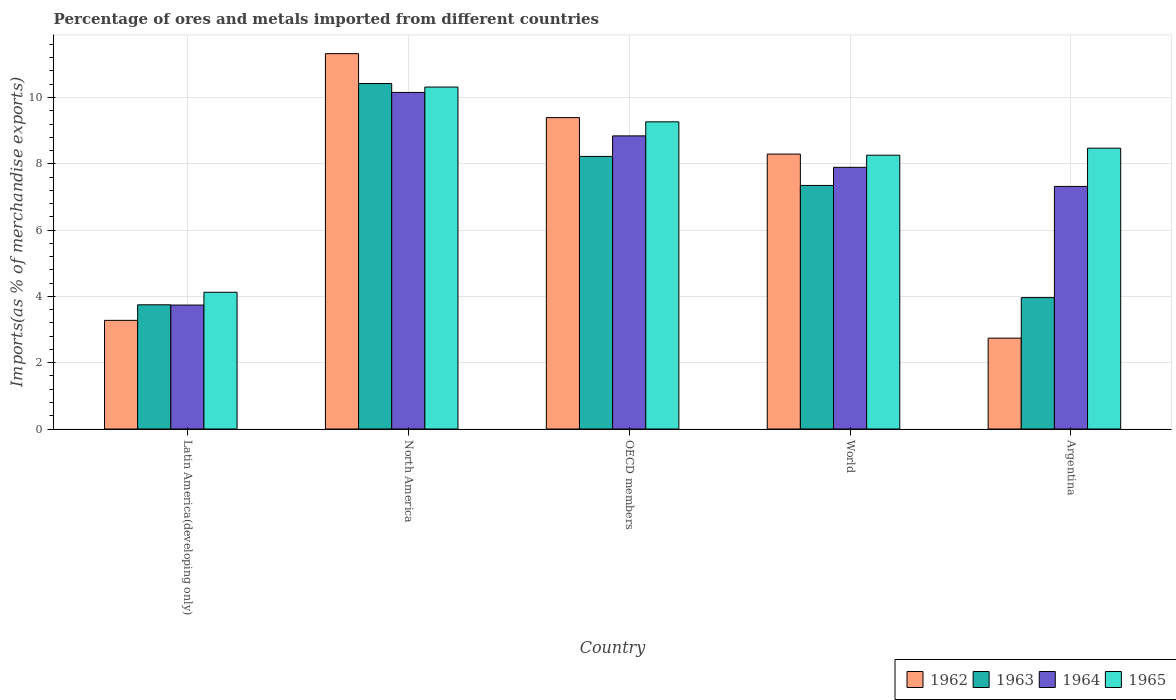How many different coloured bars are there?
Your answer should be very brief. 4. What is the label of the 1st group of bars from the left?
Your answer should be compact. Latin America(developing only). In how many cases, is the number of bars for a given country not equal to the number of legend labels?
Provide a succinct answer. 0. What is the percentage of imports to different countries in 1963 in North America?
Offer a very short reply. 10.42. Across all countries, what is the maximum percentage of imports to different countries in 1964?
Give a very brief answer. 10.15. Across all countries, what is the minimum percentage of imports to different countries in 1965?
Your answer should be compact. 4.13. In which country was the percentage of imports to different countries in 1962 maximum?
Your answer should be compact. North America. What is the total percentage of imports to different countries in 1965 in the graph?
Your answer should be compact. 40.44. What is the difference between the percentage of imports to different countries in 1962 in Argentina and that in North America?
Provide a short and direct response. -8.58. What is the difference between the percentage of imports to different countries in 1963 in World and the percentage of imports to different countries in 1962 in OECD members?
Provide a short and direct response. -2.05. What is the average percentage of imports to different countries in 1962 per country?
Your answer should be compact. 7.01. What is the difference between the percentage of imports to different countries of/in 1963 and percentage of imports to different countries of/in 1965 in OECD members?
Your response must be concise. -1.04. What is the ratio of the percentage of imports to different countries in 1965 in North America to that in OECD members?
Your response must be concise. 1.11. Is the percentage of imports to different countries in 1962 in Latin America(developing only) less than that in World?
Give a very brief answer. Yes. What is the difference between the highest and the second highest percentage of imports to different countries in 1965?
Offer a terse response. -0.79. What is the difference between the highest and the lowest percentage of imports to different countries in 1963?
Provide a short and direct response. 6.67. Is the sum of the percentage of imports to different countries in 1965 in Argentina and OECD members greater than the maximum percentage of imports to different countries in 1964 across all countries?
Ensure brevity in your answer.  Yes. Is it the case that in every country, the sum of the percentage of imports to different countries in 1963 and percentage of imports to different countries in 1964 is greater than the sum of percentage of imports to different countries in 1962 and percentage of imports to different countries in 1965?
Offer a terse response. No. What does the 3rd bar from the left in North America represents?
Provide a succinct answer. 1964. Is it the case that in every country, the sum of the percentage of imports to different countries in 1962 and percentage of imports to different countries in 1964 is greater than the percentage of imports to different countries in 1965?
Give a very brief answer. Yes. Are all the bars in the graph horizontal?
Make the answer very short. No. Are the values on the major ticks of Y-axis written in scientific E-notation?
Your answer should be very brief. No. Does the graph contain any zero values?
Provide a succinct answer. No. Where does the legend appear in the graph?
Keep it short and to the point. Bottom right. What is the title of the graph?
Keep it short and to the point. Percentage of ores and metals imported from different countries. What is the label or title of the Y-axis?
Your response must be concise. Imports(as % of merchandise exports). What is the Imports(as % of merchandise exports) of 1962 in Latin America(developing only)?
Provide a short and direct response. 3.28. What is the Imports(as % of merchandise exports) in 1963 in Latin America(developing only)?
Ensure brevity in your answer.  3.75. What is the Imports(as % of merchandise exports) in 1964 in Latin America(developing only)?
Your response must be concise. 3.74. What is the Imports(as % of merchandise exports) of 1965 in Latin America(developing only)?
Provide a short and direct response. 4.13. What is the Imports(as % of merchandise exports) in 1962 in North America?
Give a very brief answer. 11.32. What is the Imports(as % of merchandise exports) in 1963 in North America?
Offer a very short reply. 10.42. What is the Imports(as % of merchandise exports) in 1964 in North America?
Offer a very short reply. 10.15. What is the Imports(as % of merchandise exports) in 1965 in North America?
Your response must be concise. 10.31. What is the Imports(as % of merchandise exports) in 1962 in OECD members?
Provide a short and direct response. 9.39. What is the Imports(as % of merchandise exports) in 1963 in OECD members?
Offer a very short reply. 8.22. What is the Imports(as % of merchandise exports) in 1964 in OECD members?
Keep it short and to the point. 8.84. What is the Imports(as % of merchandise exports) of 1965 in OECD members?
Offer a terse response. 9.27. What is the Imports(as % of merchandise exports) in 1962 in World?
Offer a very short reply. 8.29. What is the Imports(as % of merchandise exports) in 1963 in World?
Ensure brevity in your answer.  7.35. What is the Imports(as % of merchandise exports) of 1964 in World?
Keep it short and to the point. 7.89. What is the Imports(as % of merchandise exports) of 1965 in World?
Give a very brief answer. 8.26. What is the Imports(as % of merchandise exports) of 1962 in Argentina?
Ensure brevity in your answer.  2.74. What is the Imports(as % of merchandise exports) in 1963 in Argentina?
Give a very brief answer. 3.96. What is the Imports(as % of merchandise exports) of 1964 in Argentina?
Your response must be concise. 7.32. What is the Imports(as % of merchandise exports) in 1965 in Argentina?
Your response must be concise. 8.47. Across all countries, what is the maximum Imports(as % of merchandise exports) of 1962?
Your response must be concise. 11.32. Across all countries, what is the maximum Imports(as % of merchandise exports) of 1963?
Offer a terse response. 10.42. Across all countries, what is the maximum Imports(as % of merchandise exports) of 1964?
Make the answer very short. 10.15. Across all countries, what is the maximum Imports(as % of merchandise exports) in 1965?
Offer a terse response. 10.31. Across all countries, what is the minimum Imports(as % of merchandise exports) of 1962?
Offer a terse response. 2.74. Across all countries, what is the minimum Imports(as % of merchandise exports) of 1963?
Make the answer very short. 3.75. Across all countries, what is the minimum Imports(as % of merchandise exports) in 1964?
Make the answer very short. 3.74. Across all countries, what is the minimum Imports(as % of merchandise exports) of 1965?
Keep it short and to the point. 4.13. What is the total Imports(as % of merchandise exports) of 1962 in the graph?
Your answer should be very brief. 35.03. What is the total Imports(as % of merchandise exports) of 1963 in the graph?
Your response must be concise. 33.7. What is the total Imports(as % of merchandise exports) in 1964 in the graph?
Provide a succinct answer. 37.95. What is the total Imports(as % of merchandise exports) in 1965 in the graph?
Provide a short and direct response. 40.44. What is the difference between the Imports(as % of merchandise exports) in 1962 in Latin America(developing only) and that in North America?
Your answer should be compact. -8.05. What is the difference between the Imports(as % of merchandise exports) of 1963 in Latin America(developing only) and that in North America?
Offer a very short reply. -6.67. What is the difference between the Imports(as % of merchandise exports) of 1964 in Latin America(developing only) and that in North America?
Offer a very short reply. -6.41. What is the difference between the Imports(as % of merchandise exports) of 1965 in Latin America(developing only) and that in North America?
Make the answer very short. -6.19. What is the difference between the Imports(as % of merchandise exports) of 1962 in Latin America(developing only) and that in OECD members?
Your answer should be very brief. -6.12. What is the difference between the Imports(as % of merchandise exports) of 1963 in Latin America(developing only) and that in OECD members?
Your answer should be compact. -4.48. What is the difference between the Imports(as % of merchandise exports) in 1964 in Latin America(developing only) and that in OECD members?
Give a very brief answer. -5.1. What is the difference between the Imports(as % of merchandise exports) in 1965 in Latin America(developing only) and that in OECD members?
Your answer should be compact. -5.14. What is the difference between the Imports(as % of merchandise exports) of 1962 in Latin America(developing only) and that in World?
Keep it short and to the point. -5.02. What is the difference between the Imports(as % of merchandise exports) of 1963 in Latin America(developing only) and that in World?
Your answer should be very brief. -3.6. What is the difference between the Imports(as % of merchandise exports) of 1964 in Latin America(developing only) and that in World?
Your answer should be compact. -4.15. What is the difference between the Imports(as % of merchandise exports) in 1965 in Latin America(developing only) and that in World?
Keep it short and to the point. -4.13. What is the difference between the Imports(as % of merchandise exports) of 1962 in Latin America(developing only) and that in Argentina?
Make the answer very short. 0.54. What is the difference between the Imports(as % of merchandise exports) of 1963 in Latin America(developing only) and that in Argentina?
Provide a succinct answer. -0.22. What is the difference between the Imports(as % of merchandise exports) of 1964 in Latin America(developing only) and that in Argentina?
Offer a very short reply. -3.58. What is the difference between the Imports(as % of merchandise exports) of 1965 in Latin America(developing only) and that in Argentina?
Give a very brief answer. -4.35. What is the difference between the Imports(as % of merchandise exports) of 1962 in North America and that in OECD members?
Make the answer very short. 1.93. What is the difference between the Imports(as % of merchandise exports) of 1963 in North America and that in OECD members?
Provide a succinct answer. 2.2. What is the difference between the Imports(as % of merchandise exports) of 1964 in North America and that in OECD members?
Make the answer very short. 1.31. What is the difference between the Imports(as % of merchandise exports) of 1965 in North America and that in OECD members?
Keep it short and to the point. 1.05. What is the difference between the Imports(as % of merchandise exports) of 1962 in North America and that in World?
Your answer should be compact. 3.03. What is the difference between the Imports(as % of merchandise exports) in 1963 in North America and that in World?
Provide a succinct answer. 3.07. What is the difference between the Imports(as % of merchandise exports) of 1964 in North America and that in World?
Offer a very short reply. 2.26. What is the difference between the Imports(as % of merchandise exports) in 1965 in North America and that in World?
Keep it short and to the point. 2.06. What is the difference between the Imports(as % of merchandise exports) of 1962 in North America and that in Argentina?
Your response must be concise. 8.58. What is the difference between the Imports(as % of merchandise exports) of 1963 in North America and that in Argentina?
Your answer should be very brief. 6.46. What is the difference between the Imports(as % of merchandise exports) of 1964 in North America and that in Argentina?
Give a very brief answer. 2.84. What is the difference between the Imports(as % of merchandise exports) of 1965 in North America and that in Argentina?
Give a very brief answer. 1.84. What is the difference between the Imports(as % of merchandise exports) in 1962 in OECD members and that in World?
Your response must be concise. 1.1. What is the difference between the Imports(as % of merchandise exports) in 1963 in OECD members and that in World?
Ensure brevity in your answer.  0.88. What is the difference between the Imports(as % of merchandise exports) in 1964 in OECD members and that in World?
Make the answer very short. 0.95. What is the difference between the Imports(as % of merchandise exports) of 1965 in OECD members and that in World?
Offer a very short reply. 1.01. What is the difference between the Imports(as % of merchandise exports) in 1962 in OECD members and that in Argentina?
Offer a terse response. 6.65. What is the difference between the Imports(as % of merchandise exports) of 1963 in OECD members and that in Argentina?
Your answer should be compact. 4.26. What is the difference between the Imports(as % of merchandise exports) of 1964 in OECD members and that in Argentina?
Provide a short and direct response. 1.52. What is the difference between the Imports(as % of merchandise exports) of 1965 in OECD members and that in Argentina?
Your answer should be very brief. 0.79. What is the difference between the Imports(as % of merchandise exports) in 1962 in World and that in Argentina?
Give a very brief answer. 5.55. What is the difference between the Imports(as % of merchandise exports) in 1963 in World and that in Argentina?
Offer a very short reply. 3.38. What is the difference between the Imports(as % of merchandise exports) in 1964 in World and that in Argentina?
Offer a terse response. 0.58. What is the difference between the Imports(as % of merchandise exports) in 1965 in World and that in Argentina?
Your answer should be compact. -0.21. What is the difference between the Imports(as % of merchandise exports) of 1962 in Latin America(developing only) and the Imports(as % of merchandise exports) of 1963 in North America?
Offer a terse response. -7.14. What is the difference between the Imports(as % of merchandise exports) of 1962 in Latin America(developing only) and the Imports(as % of merchandise exports) of 1964 in North America?
Provide a succinct answer. -6.88. What is the difference between the Imports(as % of merchandise exports) in 1962 in Latin America(developing only) and the Imports(as % of merchandise exports) in 1965 in North America?
Keep it short and to the point. -7.04. What is the difference between the Imports(as % of merchandise exports) in 1963 in Latin America(developing only) and the Imports(as % of merchandise exports) in 1964 in North America?
Offer a very short reply. -6.41. What is the difference between the Imports(as % of merchandise exports) of 1963 in Latin America(developing only) and the Imports(as % of merchandise exports) of 1965 in North America?
Your answer should be compact. -6.57. What is the difference between the Imports(as % of merchandise exports) in 1964 in Latin America(developing only) and the Imports(as % of merchandise exports) in 1965 in North America?
Provide a short and direct response. -6.58. What is the difference between the Imports(as % of merchandise exports) in 1962 in Latin America(developing only) and the Imports(as % of merchandise exports) in 1963 in OECD members?
Make the answer very short. -4.95. What is the difference between the Imports(as % of merchandise exports) of 1962 in Latin America(developing only) and the Imports(as % of merchandise exports) of 1964 in OECD members?
Give a very brief answer. -5.57. What is the difference between the Imports(as % of merchandise exports) in 1962 in Latin America(developing only) and the Imports(as % of merchandise exports) in 1965 in OECD members?
Provide a short and direct response. -5.99. What is the difference between the Imports(as % of merchandise exports) of 1963 in Latin America(developing only) and the Imports(as % of merchandise exports) of 1964 in OECD members?
Your response must be concise. -5.1. What is the difference between the Imports(as % of merchandise exports) in 1963 in Latin America(developing only) and the Imports(as % of merchandise exports) in 1965 in OECD members?
Your response must be concise. -5.52. What is the difference between the Imports(as % of merchandise exports) in 1964 in Latin America(developing only) and the Imports(as % of merchandise exports) in 1965 in OECD members?
Give a very brief answer. -5.53. What is the difference between the Imports(as % of merchandise exports) of 1962 in Latin America(developing only) and the Imports(as % of merchandise exports) of 1963 in World?
Provide a succinct answer. -4.07. What is the difference between the Imports(as % of merchandise exports) of 1962 in Latin America(developing only) and the Imports(as % of merchandise exports) of 1964 in World?
Keep it short and to the point. -4.62. What is the difference between the Imports(as % of merchandise exports) of 1962 in Latin America(developing only) and the Imports(as % of merchandise exports) of 1965 in World?
Offer a terse response. -4.98. What is the difference between the Imports(as % of merchandise exports) of 1963 in Latin America(developing only) and the Imports(as % of merchandise exports) of 1964 in World?
Offer a terse response. -4.15. What is the difference between the Imports(as % of merchandise exports) of 1963 in Latin America(developing only) and the Imports(as % of merchandise exports) of 1965 in World?
Offer a terse response. -4.51. What is the difference between the Imports(as % of merchandise exports) in 1964 in Latin America(developing only) and the Imports(as % of merchandise exports) in 1965 in World?
Offer a very short reply. -4.52. What is the difference between the Imports(as % of merchandise exports) of 1962 in Latin America(developing only) and the Imports(as % of merchandise exports) of 1963 in Argentina?
Keep it short and to the point. -0.69. What is the difference between the Imports(as % of merchandise exports) of 1962 in Latin America(developing only) and the Imports(as % of merchandise exports) of 1964 in Argentina?
Your response must be concise. -4.04. What is the difference between the Imports(as % of merchandise exports) of 1962 in Latin America(developing only) and the Imports(as % of merchandise exports) of 1965 in Argentina?
Provide a short and direct response. -5.19. What is the difference between the Imports(as % of merchandise exports) of 1963 in Latin America(developing only) and the Imports(as % of merchandise exports) of 1964 in Argentina?
Make the answer very short. -3.57. What is the difference between the Imports(as % of merchandise exports) of 1963 in Latin America(developing only) and the Imports(as % of merchandise exports) of 1965 in Argentina?
Provide a succinct answer. -4.73. What is the difference between the Imports(as % of merchandise exports) of 1964 in Latin America(developing only) and the Imports(as % of merchandise exports) of 1965 in Argentina?
Ensure brevity in your answer.  -4.73. What is the difference between the Imports(as % of merchandise exports) in 1962 in North America and the Imports(as % of merchandise exports) in 1963 in OECD members?
Provide a short and direct response. 3.1. What is the difference between the Imports(as % of merchandise exports) in 1962 in North America and the Imports(as % of merchandise exports) in 1964 in OECD members?
Your answer should be compact. 2.48. What is the difference between the Imports(as % of merchandise exports) in 1962 in North America and the Imports(as % of merchandise exports) in 1965 in OECD members?
Give a very brief answer. 2.06. What is the difference between the Imports(as % of merchandise exports) in 1963 in North America and the Imports(as % of merchandise exports) in 1964 in OECD members?
Keep it short and to the point. 1.58. What is the difference between the Imports(as % of merchandise exports) in 1963 in North America and the Imports(as % of merchandise exports) in 1965 in OECD members?
Offer a terse response. 1.16. What is the difference between the Imports(as % of merchandise exports) in 1964 in North America and the Imports(as % of merchandise exports) in 1965 in OECD members?
Your response must be concise. 0.89. What is the difference between the Imports(as % of merchandise exports) of 1962 in North America and the Imports(as % of merchandise exports) of 1963 in World?
Provide a short and direct response. 3.98. What is the difference between the Imports(as % of merchandise exports) of 1962 in North America and the Imports(as % of merchandise exports) of 1964 in World?
Ensure brevity in your answer.  3.43. What is the difference between the Imports(as % of merchandise exports) of 1962 in North America and the Imports(as % of merchandise exports) of 1965 in World?
Your answer should be compact. 3.06. What is the difference between the Imports(as % of merchandise exports) in 1963 in North America and the Imports(as % of merchandise exports) in 1964 in World?
Offer a very short reply. 2.53. What is the difference between the Imports(as % of merchandise exports) in 1963 in North America and the Imports(as % of merchandise exports) in 1965 in World?
Make the answer very short. 2.16. What is the difference between the Imports(as % of merchandise exports) in 1964 in North America and the Imports(as % of merchandise exports) in 1965 in World?
Provide a succinct answer. 1.89. What is the difference between the Imports(as % of merchandise exports) in 1962 in North America and the Imports(as % of merchandise exports) in 1963 in Argentina?
Your answer should be compact. 7.36. What is the difference between the Imports(as % of merchandise exports) of 1962 in North America and the Imports(as % of merchandise exports) of 1964 in Argentina?
Give a very brief answer. 4. What is the difference between the Imports(as % of merchandise exports) in 1962 in North America and the Imports(as % of merchandise exports) in 1965 in Argentina?
Your response must be concise. 2.85. What is the difference between the Imports(as % of merchandise exports) of 1963 in North America and the Imports(as % of merchandise exports) of 1964 in Argentina?
Provide a short and direct response. 3.1. What is the difference between the Imports(as % of merchandise exports) of 1963 in North America and the Imports(as % of merchandise exports) of 1965 in Argentina?
Provide a short and direct response. 1.95. What is the difference between the Imports(as % of merchandise exports) of 1964 in North America and the Imports(as % of merchandise exports) of 1965 in Argentina?
Give a very brief answer. 1.68. What is the difference between the Imports(as % of merchandise exports) of 1962 in OECD members and the Imports(as % of merchandise exports) of 1963 in World?
Offer a terse response. 2.05. What is the difference between the Imports(as % of merchandise exports) of 1962 in OECD members and the Imports(as % of merchandise exports) of 1964 in World?
Provide a short and direct response. 1.5. What is the difference between the Imports(as % of merchandise exports) in 1962 in OECD members and the Imports(as % of merchandise exports) in 1965 in World?
Offer a very short reply. 1.13. What is the difference between the Imports(as % of merchandise exports) in 1963 in OECD members and the Imports(as % of merchandise exports) in 1964 in World?
Make the answer very short. 0.33. What is the difference between the Imports(as % of merchandise exports) of 1963 in OECD members and the Imports(as % of merchandise exports) of 1965 in World?
Your response must be concise. -0.04. What is the difference between the Imports(as % of merchandise exports) of 1964 in OECD members and the Imports(as % of merchandise exports) of 1965 in World?
Your response must be concise. 0.58. What is the difference between the Imports(as % of merchandise exports) of 1962 in OECD members and the Imports(as % of merchandise exports) of 1963 in Argentina?
Your answer should be compact. 5.43. What is the difference between the Imports(as % of merchandise exports) of 1962 in OECD members and the Imports(as % of merchandise exports) of 1964 in Argentina?
Provide a succinct answer. 2.08. What is the difference between the Imports(as % of merchandise exports) in 1962 in OECD members and the Imports(as % of merchandise exports) in 1965 in Argentina?
Provide a succinct answer. 0.92. What is the difference between the Imports(as % of merchandise exports) of 1963 in OECD members and the Imports(as % of merchandise exports) of 1964 in Argentina?
Your response must be concise. 0.9. What is the difference between the Imports(as % of merchandise exports) in 1963 in OECD members and the Imports(as % of merchandise exports) in 1965 in Argentina?
Provide a succinct answer. -0.25. What is the difference between the Imports(as % of merchandise exports) in 1964 in OECD members and the Imports(as % of merchandise exports) in 1965 in Argentina?
Your answer should be very brief. 0.37. What is the difference between the Imports(as % of merchandise exports) in 1962 in World and the Imports(as % of merchandise exports) in 1963 in Argentina?
Your response must be concise. 4.33. What is the difference between the Imports(as % of merchandise exports) of 1962 in World and the Imports(as % of merchandise exports) of 1964 in Argentina?
Provide a short and direct response. 0.98. What is the difference between the Imports(as % of merchandise exports) of 1962 in World and the Imports(as % of merchandise exports) of 1965 in Argentina?
Ensure brevity in your answer.  -0.18. What is the difference between the Imports(as % of merchandise exports) in 1963 in World and the Imports(as % of merchandise exports) in 1964 in Argentina?
Provide a succinct answer. 0.03. What is the difference between the Imports(as % of merchandise exports) of 1963 in World and the Imports(as % of merchandise exports) of 1965 in Argentina?
Make the answer very short. -1.12. What is the difference between the Imports(as % of merchandise exports) of 1964 in World and the Imports(as % of merchandise exports) of 1965 in Argentina?
Keep it short and to the point. -0.58. What is the average Imports(as % of merchandise exports) of 1962 per country?
Make the answer very short. 7.01. What is the average Imports(as % of merchandise exports) of 1963 per country?
Give a very brief answer. 6.74. What is the average Imports(as % of merchandise exports) of 1964 per country?
Keep it short and to the point. 7.59. What is the average Imports(as % of merchandise exports) in 1965 per country?
Offer a terse response. 8.09. What is the difference between the Imports(as % of merchandise exports) in 1962 and Imports(as % of merchandise exports) in 1963 in Latin America(developing only)?
Your answer should be compact. -0.47. What is the difference between the Imports(as % of merchandise exports) in 1962 and Imports(as % of merchandise exports) in 1964 in Latin America(developing only)?
Offer a terse response. -0.46. What is the difference between the Imports(as % of merchandise exports) of 1962 and Imports(as % of merchandise exports) of 1965 in Latin America(developing only)?
Provide a succinct answer. -0.85. What is the difference between the Imports(as % of merchandise exports) of 1963 and Imports(as % of merchandise exports) of 1964 in Latin America(developing only)?
Offer a very short reply. 0.01. What is the difference between the Imports(as % of merchandise exports) in 1963 and Imports(as % of merchandise exports) in 1965 in Latin America(developing only)?
Provide a succinct answer. -0.38. What is the difference between the Imports(as % of merchandise exports) in 1964 and Imports(as % of merchandise exports) in 1965 in Latin America(developing only)?
Your response must be concise. -0.39. What is the difference between the Imports(as % of merchandise exports) of 1962 and Imports(as % of merchandise exports) of 1963 in North America?
Offer a very short reply. 0.9. What is the difference between the Imports(as % of merchandise exports) of 1962 and Imports(as % of merchandise exports) of 1964 in North America?
Provide a short and direct response. 1.17. What is the difference between the Imports(as % of merchandise exports) in 1963 and Imports(as % of merchandise exports) in 1964 in North America?
Ensure brevity in your answer.  0.27. What is the difference between the Imports(as % of merchandise exports) of 1963 and Imports(as % of merchandise exports) of 1965 in North America?
Offer a terse response. 0.11. What is the difference between the Imports(as % of merchandise exports) of 1964 and Imports(as % of merchandise exports) of 1965 in North America?
Offer a terse response. -0.16. What is the difference between the Imports(as % of merchandise exports) of 1962 and Imports(as % of merchandise exports) of 1963 in OECD members?
Provide a short and direct response. 1.17. What is the difference between the Imports(as % of merchandise exports) in 1962 and Imports(as % of merchandise exports) in 1964 in OECD members?
Give a very brief answer. 0.55. What is the difference between the Imports(as % of merchandise exports) of 1962 and Imports(as % of merchandise exports) of 1965 in OECD members?
Your answer should be very brief. 0.13. What is the difference between the Imports(as % of merchandise exports) of 1963 and Imports(as % of merchandise exports) of 1964 in OECD members?
Keep it short and to the point. -0.62. What is the difference between the Imports(as % of merchandise exports) in 1963 and Imports(as % of merchandise exports) in 1965 in OECD members?
Provide a short and direct response. -1.04. What is the difference between the Imports(as % of merchandise exports) of 1964 and Imports(as % of merchandise exports) of 1965 in OECD members?
Give a very brief answer. -0.42. What is the difference between the Imports(as % of merchandise exports) of 1962 and Imports(as % of merchandise exports) of 1963 in World?
Keep it short and to the point. 0.95. What is the difference between the Imports(as % of merchandise exports) in 1962 and Imports(as % of merchandise exports) in 1964 in World?
Keep it short and to the point. 0.4. What is the difference between the Imports(as % of merchandise exports) in 1962 and Imports(as % of merchandise exports) in 1965 in World?
Keep it short and to the point. 0.03. What is the difference between the Imports(as % of merchandise exports) in 1963 and Imports(as % of merchandise exports) in 1964 in World?
Your answer should be compact. -0.55. What is the difference between the Imports(as % of merchandise exports) in 1963 and Imports(as % of merchandise exports) in 1965 in World?
Give a very brief answer. -0.91. What is the difference between the Imports(as % of merchandise exports) in 1964 and Imports(as % of merchandise exports) in 1965 in World?
Your response must be concise. -0.37. What is the difference between the Imports(as % of merchandise exports) in 1962 and Imports(as % of merchandise exports) in 1963 in Argentina?
Your response must be concise. -1.22. What is the difference between the Imports(as % of merchandise exports) of 1962 and Imports(as % of merchandise exports) of 1964 in Argentina?
Make the answer very short. -4.58. What is the difference between the Imports(as % of merchandise exports) in 1962 and Imports(as % of merchandise exports) in 1965 in Argentina?
Provide a succinct answer. -5.73. What is the difference between the Imports(as % of merchandise exports) of 1963 and Imports(as % of merchandise exports) of 1964 in Argentina?
Ensure brevity in your answer.  -3.35. What is the difference between the Imports(as % of merchandise exports) in 1963 and Imports(as % of merchandise exports) in 1965 in Argentina?
Offer a terse response. -4.51. What is the difference between the Imports(as % of merchandise exports) in 1964 and Imports(as % of merchandise exports) in 1965 in Argentina?
Your response must be concise. -1.15. What is the ratio of the Imports(as % of merchandise exports) in 1962 in Latin America(developing only) to that in North America?
Your answer should be very brief. 0.29. What is the ratio of the Imports(as % of merchandise exports) of 1963 in Latin America(developing only) to that in North America?
Make the answer very short. 0.36. What is the ratio of the Imports(as % of merchandise exports) of 1964 in Latin America(developing only) to that in North America?
Your response must be concise. 0.37. What is the ratio of the Imports(as % of merchandise exports) of 1965 in Latin America(developing only) to that in North America?
Offer a terse response. 0.4. What is the ratio of the Imports(as % of merchandise exports) in 1962 in Latin America(developing only) to that in OECD members?
Your answer should be compact. 0.35. What is the ratio of the Imports(as % of merchandise exports) in 1963 in Latin America(developing only) to that in OECD members?
Your answer should be very brief. 0.46. What is the ratio of the Imports(as % of merchandise exports) of 1964 in Latin America(developing only) to that in OECD members?
Offer a terse response. 0.42. What is the ratio of the Imports(as % of merchandise exports) in 1965 in Latin America(developing only) to that in OECD members?
Provide a succinct answer. 0.45. What is the ratio of the Imports(as % of merchandise exports) in 1962 in Latin America(developing only) to that in World?
Offer a terse response. 0.4. What is the ratio of the Imports(as % of merchandise exports) of 1963 in Latin America(developing only) to that in World?
Make the answer very short. 0.51. What is the ratio of the Imports(as % of merchandise exports) in 1964 in Latin America(developing only) to that in World?
Offer a terse response. 0.47. What is the ratio of the Imports(as % of merchandise exports) of 1965 in Latin America(developing only) to that in World?
Your response must be concise. 0.5. What is the ratio of the Imports(as % of merchandise exports) in 1962 in Latin America(developing only) to that in Argentina?
Offer a terse response. 1.2. What is the ratio of the Imports(as % of merchandise exports) in 1963 in Latin America(developing only) to that in Argentina?
Your answer should be compact. 0.95. What is the ratio of the Imports(as % of merchandise exports) of 1964 in Latin America(developing only) to that in Argentina?
Your answer should be very brief. 0.51. What is the ratio of the Imports(as % of merchandise exports) of 1965 in Latin America(developing only) to that in Argentina?
Your answer should be very brief. 0.49. What is the ratio of the Imports(as % of merchandise exports) of 1962 in North America to that in OECD members?
Provide a succinct answer. 1.21. What is the ratio of the Imports(as % of merchandise exports) of 1963 in North America to that in OECD members?
Your answer should be very brief. 1.27. What is the ratio of the Imports(as % of merchandise exports) of 1964 in North America to that in OECD members?
Offer a very short reply. 1.15. What is the ratio of the Imports(as % of merchandise exports) of 1965 in North America to that in OECD members?
Offer a very short reply. 1.11. What is the ratio of the Imports(as % of merchandise exports) of 1962 in North America to that in World?
Make the answer very short. 1.37. What is the ratio of the Imports(as % of merchandise exports) of 1963 in North America to that in World?
Your answer should be compact. 1.42. What is the ratio of the Imports(as % of merchandise exports) of 1964 in North America to that in World?
Keep it short and to the point. 1.29. What is the ratio of the Imports(as % of merchandise exports) in 1965 in North America to that in World?
Your answer should be compact. 1.25. What is the ratio of the Imports(as % of merchandise exports) of 1962 in North America to that in Argentina?
Make the answer very short. 4.13. What is the ratio of the Imports(as % of merchandise exports) of 1963 in North America to that in Argentina?
Give a very brief answer. 2.63. What is the ratio of the Imports(as % of merchandise exports) of 1964 in North America to that in Argentina?
Your answer should be very brief. 1.39. What is the ratio of the Imports(as % of merchandise exports) in 1965 in North America to that in Argentina?
Give a very brief answer. 1.22. What is the ratio of the Imports(as % of merchandise exports) of 1962 in OECD members to that in World?
Provide a succinct answer. 1.13. What is the ratio of the Imports(as % of merchandise exports) in 1963 in OECD members to that in World?
Offer a very short reply. 1.12. What is the ratio of the Imports(as % of merchandise exports) in 1964 in OECD members to that in World?
Keep it short and to the point. 1.12. What is the ratio of the Imports(as % of merchandise exports) in 1965 in OECD members to that in World?
Provide a succinct answer. 1.12. What is the ratio of the Imports(as % of merchandise exports) of 1962 in OECD members to that in Argentina?
Make the answer very short. 3.43. What is the ratio of the Imports(as % of merchandise exports) in 1963 in OECD members to that in Argentina?
Offer a very short reply. 2.07. What is the ratio of the Imports(as % of merchandise exports) of 1964 in OECD members to that in Argentina?
Provide a succinct answer. 1.21. What is the ratio of the Imports(as % of merchandise exports) of 1965 in OECD members to that in Argentina?
Your answer should be very brief. 1.09. What is the ratio of the Imports(as % of merchandise exports) of 1962 in World to that in Argentina?
Give a very brief answer. 3.03. What is the ratio of the Imports(as % of merchandise exports) in 1963 in World to that in Argentina?
Provide a short and direct response. 1.85. What is the ratio of the Imports(as % of merchandise exports) in 1964 in World to that in Argentina?
Your response must be concise. 1.08. What is the ratio of the Imports(as % of merchandise exports) of 1965 in World to that in Argentina?
Give a very brief answer. 0.97. What is the difference between the highest and the second highest Imports(as % of merchandise exports) in 1962?
Provide a succinct answer. 1.93. What is the difference between the highest and the second highest Imports(as % of merchandise exports) of 1963?
Ensure brevity in your answer.  2.2. What is the difference between the highest and the second highest Imports(as % of merchandise exports) of 1964?
Your answer should be very brief. 1.31. What is the difference between the highest and the second highest Imports(as % of merchandise exports) of 1965?
Give a very brief answer. 1.05. What is the difference between the highest and the lowest Imports(as % of merchandise exports) of 1962?
Provide a succinct answer. 8.58. What is the difference between the highest and the lowest Imports(as % of merchandise exports) in 1963?
Your response must be concise. 6.67. What is the difference between the highest and the lowest Imports(as % of merchandise exports) in 1964?
Keep it short and to the point. 6.41. What is the difference between the highest and the lowest Imports(as % of merchandise exports) in 1965?
Offer a very short reply. 6.19. 